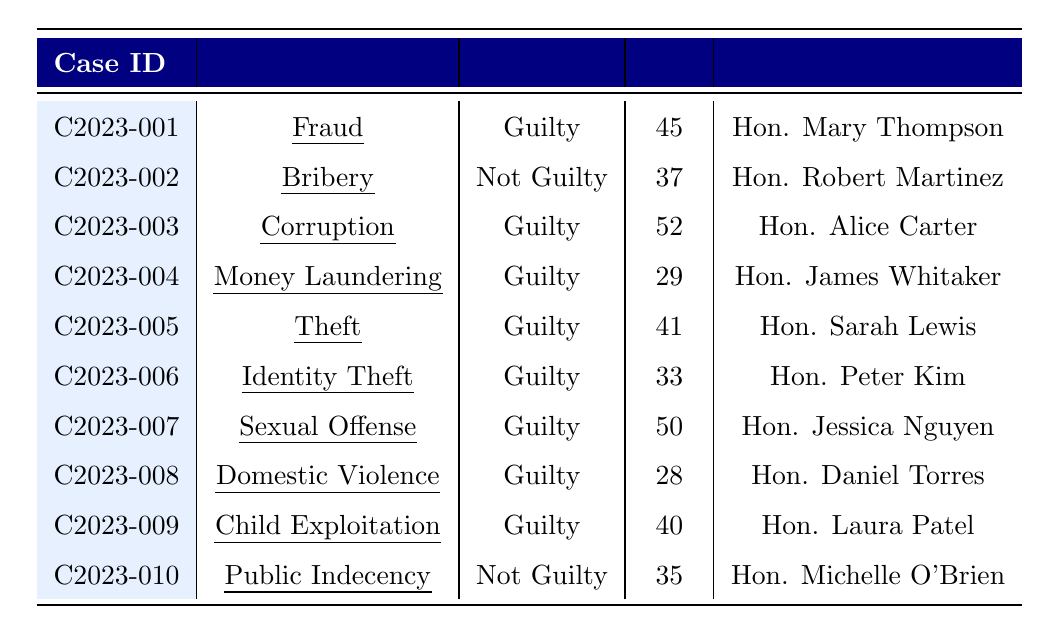What is the offense type for case C2023-003? The offense type for case C2023-003 can be found in the table under the corresponding case ID. Looking across that row, the offense type listed is "Corruption."
Answer: Corruption How many cases resulted in a "Not Guilty" verdict? There are two cases with the verdict "Not Guilty." These are for case C2023-002 (Bribery) and case C2023-010 (Public Indecency).
Answer: 2 What is the average age of defendants in the cases with a "Guilty" verdict? From the table, we identify the ages of the defendants with a "Guilty" verdict: 45, 52, 29, 41, 33, 50, 28, 40. Adding these ages gives 45 + 52 + 29 + 41 + 33 + 50 + 28 + 40 = 318. There are a total of 8 such cases, so the average age is 318/8 = 39.75.
Answer: 39.75 Which judge presided over the case involving "Child Exploitation"? The table shows that the case categorized as "Child Exploitation" is C2023-009. By checking that row, it indicates that the judge is Hon. Laura Patel.
Answer: Hon. Laura Patel Was there a case involving "Domestic Violence" that resulted in a "Not Guilty" verdict? Referring to the table, the case labeled as "Domestic Violence" is C2023-008, which resulted in a "Guilty" verdict. Therefore, the answer is no; there was no "Domestic Violence" case with a "Not Guilty" verdict.
Answer: No What is the total number of years of imprisonment ascribed to the cases with a "Guilty" verdict? The sentences that involve imprisonment (with "Guilty" verdicts) include: 10 years (Case C2023-003), 7 years (Case C2023-004), 3 years (Case C2023-005), 4 years (Case C2023-006), 15 years (Case C2023-007), and 20 years (Case C2023-009). Summing these gives: 10 + 7 + 3 + 4 + 15 + 20 = 59 years.
Answer: 59 years Which case has the highest sentence, and what is that sentence? The case with the highest sentence can be found by comparing the imprisonment periods. The longest sentence is for C2023-009, which is 20 years of imprisonment.
Answer: C2023-009, 20 years imprisonment How many years of probation are assigned to cases resulting in a "Guilty" verdict? Examining the sentences for cases with a "Guilty" verdict, we see that there are 5 years probation (C2023-001), 3 years probation (C2023-005), and 2 years probation (C2023-008). Adding these numbers gives a total of 5 + 3 + 2 = 10 years of probation.
Answer: 10 years What is the most common offense type among the cases presented? To find the most common offense type, we review the offense types: Fraud, Bribery, Corruption, Money Laundering, Theft, Identity Theft, Sexual Offense, Domestic Violence, Child Exploitation, and Public Indecency. Each offense type only appears once, so no offense type is more common than another.
Answer: None, all are unique What percentage of the cases resulted in a "Guilty" verdict? There are 10 cases in total. Out of these, 8 cases resulted in a "Guilty" verdict. Therefore, the percentage is (8/10) * 100 = 80%.
Answer: 80% 